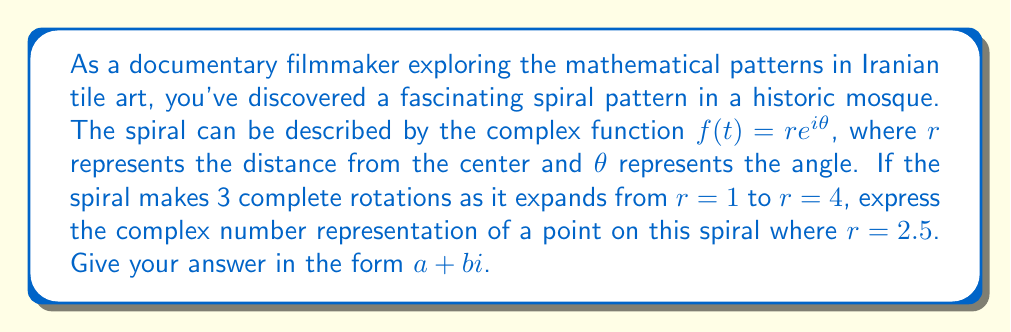Solve this math problem. To solve this problem, let's follow these steps:

1) First, we need to understand the relationship between $r$ and $\theta$. We know that:
   - The spiral starts at $r = 1$ and ends at $r = 4$
   - It makes 3 complete rotations

2) One complete rotation is $2\pi$ radians. So, 3 rotations would be $6\pi$ radians.

3) We can set up a proportion to find $\theta$ for any given $r$:
   
   $$\frac{\theta}{6\pi} = \frac{\ln(r)}{\ln(4)}$$

4) For $r = 2.5$, we can calculate $\theta$:

   $$\theta = 6\pi \cdot \frac{\ln(2.5)}{\ln(4)} \approx 4.8185 \text{ radians}$$

5) Now we have both $r$ and $\theta$. We can use Euler's formula to express this as a complex number:

   $$f(t) = re^{i\theta} = r(\cos\theta + i\sin\theta)$$

6) Substituting our values:

   $$f(t) = 2.5(\cos(4.8185) + i\sin(4.8185))$$

7) Calculating:
   
   $$f(t) \approx 2.5(-0.9466 + i \cdot 0.3224) \approx -2.3665 + 0.8060i$$

Thus, the point on the spiral can be represented by the complex number $-2.3665 + 0.8060i$.
Answer: $-2.3665 + 0.8060i$ 